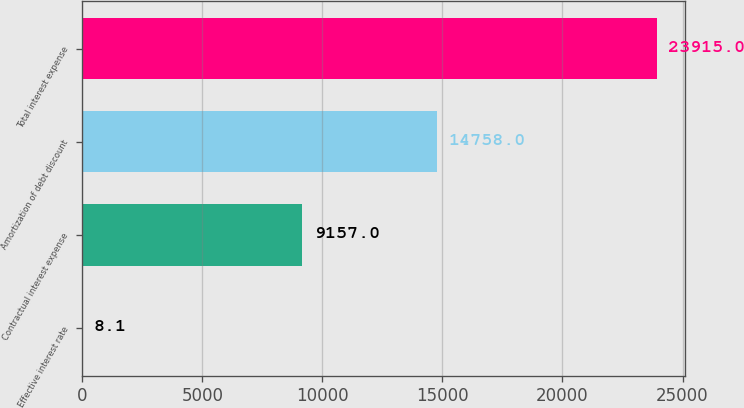Convert chart to OTSL. <chart><loc_0><loc_0><loc_500><loc_500><bar_chart><fcel>Effective interest rate<fcel>Contractual interest expense<fcel>Amortization of debt discount<fcel>Total interest expense<nl><fcel>8.1<fcel>9157<fcel>14758<fcel>23915<nl></chart> 